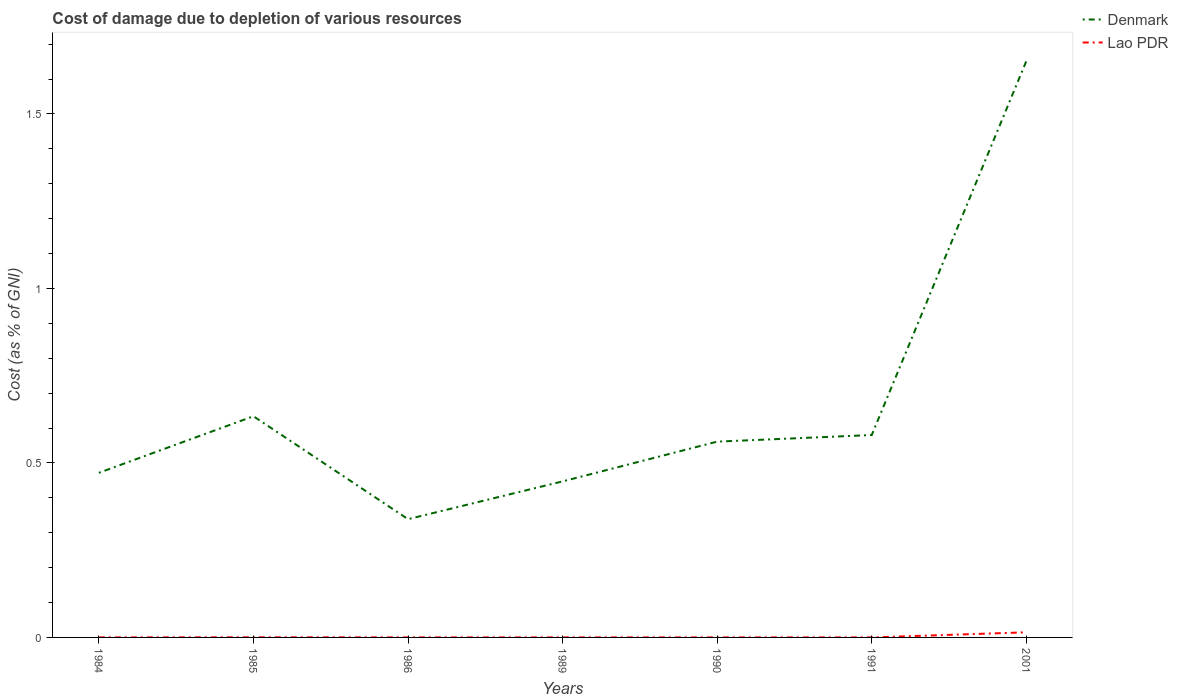How many different coloured lines are there?
Your answer should be compact. 2. Is the number of lines equal to the number of legend labels?
Provide a succinct answer. Yes. Across all years, what is the maximum cost of damage caused due to the depletion of various resources in Lao PDR?
Your response must be concise. 5.99881695392903e-5. What is the total cost of damage caused due to the depletion of various resources in Denmark in the graph?
Provide a succinct answer. -1.31. What is the difference between the highest and the second highest cost of damage caused due to the depletion of various resources in Lao PDR?
Offer a terse response. 0.01. How many lines are there?
Your response must be concise. 2. What is the difference between two consecutive major ticks on the Y-axis?
Provide a short and direct response. 0.5. Does the graph contain any zero values?
Give a very brief answer. No. Does the graph contain grids?
Give a very brief answer. No. Where does the legend appear in the graph?
Give a very brief answer. Top right. How many legend labels are there?
Give a very brief answer. 2. What is the title of the graph?
Keep it short and to the point. Cost of damage due to depletion of various resources. What is the label or title of the Y-axis?
Offer a very short reply. Cost (as % of GNI). What is the Cost (as % of GNI) in Denmark in 1984?
Your answer should be compact. 0.47. What is the Cost (as % of GNI) of Lao PDR in 1984?
Keep it short and to the point. 0. What is the Cost (as % of GNI) in Denmark in 1985?
Offer a terse response. 0.63. What is the Cost (as % of GNI) in Lao PDR in 1985?
Your answer should be compact. 0. What is the Cost (as % of GNI) in Denmark in 1986?
Keep it short and to the point. 0.34. What is the Cost (as % of GNI) of Lao PDR in 1986?
Provide a short and direct response. 0. What is the Cost (as % of GNI) in Denmark in 1989?
Your answer should be compact. 0.45. What is the Cost (as % of GNI) in Lao PDR in 1989?
Your answer should be compact. 7.44864051675228e-5. What is the Cost (as % of GNI) of Denmark in 1990?
Ensure brevity in your answer.  0.56. What is the Cost (as % of GNI) of Lao PDR in 1990?
Offer a very short reply. 0. What is the Cost (as % of GNI) of Denmark in 1991?
Make the answer very short. 0.58. What is the Cost (as % of GNI) in Lao PDR in 1991?
Give a very brief answer. 5.99881695392903e-5. What is the Cost (as % of GNI) of Denmark in 2001?
Offer a terse response. 1.65. What is the Cost (as % of GNI) in Lao PDR in 2001?
Your answer should be very brief. 0.01. Across all years, what is the maximum Cost (as % of GNI) of Denmark?
Ensure brevity in your answer.  1.65. Across all years, what is the maximum Cost (as % of GNI) in Lao PDR?
Ensure brevity in your answer.  0.01. Across all years, what is the minimum Cost (as % of GNI) in Denmark?
Ensure brevity in your answer.  0.34. Across all years, what is the minimum Cost (as % of GNI) in Lao PDR?
Provide a short and direct response. 5.99881695392903e-5. What is the total Cost (as % of GNI) in Denmark in the graph?
Your answer should be compact. 4.68. What is the total Cost (as % of GNI) in Lao PDR in the graph?
Offer a very short reply. 0.02. What is the difference between the Cost (as % of GNI) of Denmark in 1984 and that in 1985?
Offer a terse response. -0.16. What is the difference between the Cost (as % of GNI) in Lao PDR in 1984 and that in 1985?
Offer a terse response. -0. What is the difference between the Cost (as % of GNI) of Denmark in 1984 and that in 1986?
Provide a short and direct response. 0.13. What is the difference between the Cost (as % of GNI) in Denmark in 1984 and that in 1989?
Your answer should be compact. 0.02. What is the difference between the Cost (as % of GNI) of Lao PDR in 1984 and that in 1989?
Your answer should be very brief. 0. What is the difference between the Cost (as % of GNI) of Denmark in 1984 and that in 1990?
Offer a very short reply. -0.09. What is the difference between the Cost (as % of GNI) of Denmark in 1984 and that in 1991?
Your answer should be compact. -0.11. What is the difference between the Cost (as % of GNI) of Lao PDR in 1984 and that in 1991?
Your answer should be compact. 0. What is the difference between the Cost (as % of GNI) in Denmark in 1984 and that in 2001?
Your response must be concise. -1.18. What is the difference between the Cost (as % of GNI) in Lao PDR in 1984 and that in 2001?
Your response must be concise. -0.01. What is the difference between the Cost (as % of GNI) of Denmark in 1985 and that in 1986?
Offer a very short reply. 0.29. What is the difference between the Cost (as % of GNI) of Denmark in 1985 and that in 1989?
Your response must be concise. 0.19. What is the difference between the Cost (as % of GNI) in Denmark in 1985 and that in 1990?
Your answer should be compact. 0.07. What is the difference between the Cost (as % of GNI) of Denmark in 1985 and that in 1991?
Keep it short and to the point. 0.05. What is the difference between the Cost (as % of GNI) of Denmark in 1985 and that in 2001?
Make the answer very short. -1.02. What is the difference between the Cost (as % of GNI) of Lao PDR in 1985 and that in 2001?
Your answer should be compact. -0.01. What is the difference between the Cost (as % of GNI) in Denmark in 1986 and that in 1989?
Offer a terse response. -0.11. What is the difference between the Cost (as % of GNI) of Denmark in 1986 and that in 1990?
Ensure brevity in your answer.  -0.22. What is the difference between the Cost (as % of GNI) in Denmark in 1986 and that in 1991?
Give a very brief answer. -0.24. What is the difference between the Cost (as % of GNI) in Denmark in 1986 and that in 2001?
Your response must be concise. -1.31. What is the difference between the Cost (as % of GNI) in Lao PDR in 1986 and that in 2001?
Keep it short and to the point. -0.01. What is the difference between the Cost (as % of GNI) in Denmark in 1989 and that in 1990?
Ensure brevity in your answer.  -0.11. What is the difference between the Cost (as % of GNI) of Lao PDR in 1989 and that in 1990?
Ensure brevity in your answer.  -0. What is the difference between the Cost (as % of GNI) of Denmark in 1989 and that in 1991?
Give a very brief answer. -0.13. What is the difference between the Cost (as % of GNI) of Lao PDR in 1989 and that in 1991?
Provide a succinct answer. 0. What is the difference between the Cost (as % of GNI) of Denmark in 1989 and that in 2001?
Offer a very short reply. -1.2. What is the difference between the Cost (as % of GNI) of Lao PDR in 1989 and that in 2001?
Your response must be concise. -0.01. What is the difference between the Cost (as % of GNI) in Denmark in 1990 and that in 1991?
Give a very brief answer. -0.02. What is the difference between the Cost (as % of GNI) of Lao PDR in 1990 and that in 1991?
Offer a very short reply. 0. What is the difference between the Cost (as % of GNI) of Denmark in 1990 and that in 2001?
Offer a terse response. -1.09. What is the difference between the Cost (as % of GNI) in Lao PDR in 1990 and that in 2001?
Give a very brief answer. -0.01. What is the difference between the Cost (as % of GNI) of Denmark in 1991 and that in 2001?
Offer a terse response. -1.07. What is the difference between the Cost (as % of GNI) of Lao PDR in 1991 and that in 2001?
Offer a terse response. -0.01. What is the difference between the Cost (as % of GNI) in Denmark in 1984 and the Cost (as % of GNI) in Lao PDR in 1985?
Your response must be concise. 0.47. What is the difference between the Cost (as % of GNI) in Denmark in 1984 and the Cost (as % of GNI) in Lao PDR in 1986?
Ensure brevity in your answer.  0.47. What is the difference between the Cost (as % of GNI) of Denmark in 1984 and the Cost (as % of GNI) of Lao PDR in 1989?
Give a very brief answer. 0.47. What is the difference between the Cost (as % of GNI) in Denmark in 1984 and the Cost (as % of GNI) in Lao PDR in 1990?
Give a very brief answer. 0.47. What is the difference between the Cost (as % of GNI) of Denmark in 1984 and the Cost (as % of GNI) of Lao PDR in 1991?
Keep it short and to the point. 0.47. What is the difference between the Cost (as % of GNI) of Denmark in 1984 and the Cost (as % of GNI) of Lao PDR in 2001?
Your response must be concise. 0.46. What is the difference between the Cost (as % of GNI) of Denmark in 1985 and the Cost (as % of GNI) of Lao PDR in 1986?
Keep it short and to the point. 0.63. What is the difference between the Cost (as % of GNI) in Denmark in 1985 and the Cost (as % of GNI) in Lao PDR in 1989?
Make the answer very short. 0.63. What is the difference between the Cost (as % of GNI) of Denmark in 1985 and the Cost (as % of GNI) of Lao PDR in 1990?
Provide a short and direct response. 0.63. What is the difference between the Cost (as % of GNI) of Denmark in 1985 and the Cost (as % of GNI) of Lao PDR in 1991?
Your answer should be compact. 0.63. What is the difference between the Cost (as % of GNI) in Denmark in 1985 and the Cost (as % of GNI) in Lao PDR in 2001?
Give a very brief answer. 0.62. What is the difference between the Cost (as % of GNI) in Denmark in 1986 and the Cost (as % of GNI) in Lao PDR in 1989?
Your answer should be very brief. 0.34. What is the difference between the Cost (as % of GNI) of Denmark in 1986 and the Cost (as % of GNI) of Lao PDR in 1990?
Provide a succinct answer. 0.34. What is the difference between the Cost (as % of GNI) in Denmark in 1986 and the Cost (as % of GNI) in Lao PDR in 1991?
Ensure brevity in your answer.  0.34. What is the difference between the Cost (as % of GNI) in Denmark in 1986 and the Cost (as % of GNI) in Lao PDR in 2001?
Your answer should be very brief. 0.32. What is the difference between the Cost (as % of GNI) in Denmark in 1989 and the Cost (as % of GNI) in Lao PDR in 1990?
Offer a very short reply. 0.45. What is the difference between the Cost (as % of GNI) of Denmark in 1989 and the Cost (as % of GNI) of Lao PDR in 1991?
Ensure brevity in your answer.  0.45. What is the difference between the Cost (as % of GNI) of Denmark in 1989 and the Cost (as % of GNI) of Lao PDR in 2001?
Provide a short and direct response. 0.43. What is the difference between the Cost (as % of GNI) in Denmark in 1990 and the Cost (as % of GNI) in Lao PDR in 1991?
Your answer should be compact. 0.56. What is the difference between the Cost (as % of GNI) of Denmark in 1990 and the Cost (as % of GNI) of Lao PDR in 2001?
Your answer should be very brief. 0.55. What is the difference between the Cost (as % of GNI) of Denmark in 1991 and the Cost (as % of GNI) of Lao PDR in 2001?
Ensure brevity in your answer.  0.57. What is the average Cost (as % of GNI) in Denmark per year?
Keep it short and to the point. 0.67. What is the average Cost (as % of GNI) of Lao PDR per year?
Offer a terse response. 0. In the year 1984, what is the difference between the Cost (as % of GNI) of Denmark and Cost (as % of GNI) of Lao PDR?
Give a very brief answer. 0.47. In the year 1985, what is the difference between the Cost (as % of GNI) of Denmark and Cost (as % of GNI) of Lao PDR?
Your answer should be very brief. 0.63. In the year 1986, what is the difference between the Cost (as % of GNI) in Denmark and Cost (as % of GNI) in Lao PDR?
Your answer should be very brief. 0.34. In the year 1989, what is the difference between the Cost (as % of GNI) in Denmark and Cost (as % of GNI) in Lao PDR?
Your answer should be very brief. 0.45. In the year 1990, what is the difference between the Cost (as % of GNI) of Denmark and Cost (as % of GNI) of Lao PDR?
Offer a very short reply. 0.56. In the year 1991, what is the difference between the Cost (as % of GNI) in Denmark and Cost (as % of GNI) in Lao PDR?
Offer a very short reply. 0.58. In the year 2001, what is the difference between the Cost (as % of GNI) of Denmark and Cost (as % of GNI) of Lao PDR?
Provide a short and direct response. 1.64. What is the ratio of the Cost (as % of GNI) in Denmark in 1984 to that in 1985?
Ensure brevity in your answer.  0.74. What is the ratio of the Cost (as % of GNI) in Lao PDR in 1984 to that in 1985?
Give a very brief answer. 0.38. What is the ratio of the Cost (as % of GNI) of Denmark in 1984 to that in 1986?
Give a very brief answer. 1.39. What is the ratio of the Cost (as % of GNI) of Lao PDR in 1984 to that in 1986?
Ensure brevity in your answer.  0.78. What is the ratio of the Cost (as % of GNI) of Denmark in 1984 to that in 1989?
Give a very brief answer. 1.05. What is the ratio of the Cost (as % of GNI) in Lao PDR in 1984 to that in 1989?
Make the answer very short. 1.54. What is the ratio of the Cost (as % of GNI) in Denmark in 1984 to that in 1990?
Offer a terse response. 0.84. What is the ratio of the Cost (as % of GNI) of Lao PDR in 1984 to that in 1990?
Your answer should be very brief. 1.08. What is the ratio of the Cost (as % of GNI) in Denmark in 1984 to that in 1991?
Your answer should be compact. 0.81. What is the ratio of the Cost (as % of GNI) of Lao PDR in 1984 to that in 1991?
Give a very brief answer. 1.91. What is the ratio of the Cost (as % of GNI) of Denmark in 1984 to that in 2001?
Give a very brief answer. 0.29. What is the ratio of the Cost (as % of GNI) in Lao PDR in 1984 to that in 2001?
Provide a short and direct response. 0.01. What is the ratio of the Cost (as % of GNI) in Denmark in 1985 to that in 1986?
Offer a terse response. 1.87. What is the ratio of the Cost (as % of GNI) of Lao PDR in 1985 to that in 1986?
Make the answer very short. 2.06. What is the ratio of the Cost (as % of GNI) of Denmark in 1985 to that in 1989?
Provide a succinct answer. 1.42. What is the ratio of the Cost (as % of GNI) of Lao PDR in 1985 to that in 1989?
Your response must be concise. 4.06. What is the ratio of the Cost (as % of GNI) in Denmark in 1985 to that in 1990?
Offer a very short reply. 1.13. What is the ratio of the Cost (as % of GNI) in Lao PDR in 1985 to that in 1990?
Ensure brevity in your answer.  2.85. What is the ratio of the Cost (as % of GNI) in Denmark in 1985 to that in 1991?
Your answer should be compact. 1.09. What is the ratio of the Cost (as % of GNI) of Lao PDR in 1985 to that in 1991?
Provide a short and direct response. 5.04. What is the ratio of the Cost (as % of GNI) of Denmark in 1985 to that in 2001?
Make the answer very short. 0.38. What is the ratio of the Cost (as % of GNI) of Lao PDR in 1985 to that in 2001?
Your answer should be compact. 0.02. What is the ratio of the Cost (as % of GNI) in Denmark in 1986 to that in 1989?
Provide a succinct answer. 0.76. What is the ratio of the Cost (as % of GNI) of Lao PDR in 1986 to that in 1989?
Provide a short and direct response. 1.97. What is the ratio of the Cost (as % of GNI) in Denmark in 1986 to that in 1990?
Provide a short and direct response. 0.6. What is the ratio of the Cost (as % of GNI) in Lao PDR in 1986 to that in 1990?
Your response must be concise. 1.38. What is the ratio of the Cost (as % of GNI) in Denmark in 1986 to that in 1991?
Give a very brief answer. 0.58. What is the ratio of the Cost (as % of GNI) of Lao PDR in 1986 to that in 1991?
Provide a short and direct response. 2.44. What is the ratio of the Cost (as % of GNI) of Denmark in 1986 to that in 2001?
Offer a very short reply. 0.21. What is the ratio of the Cost (as % of GNI) in Denmark in 1989 to that in 1990?
Offer a terse response. 0.8. What is the ratio of the Cost (as % of GNI) in Lao PDR in 1989 to that in 1990?
Ensure brevity in your answer.  0.7. What is the ratio of the Cost (as % of GNI) in Denmark in 1989 to that in 1991?
Keep it short and to the point. 0.77. What is the ratio of the Cost (as % of GNI) of Lao PDR in 1989 to that in 1991?
Give a very brief answer. 1.24. What is the ratio of the Cost (as % of GNI) in Denmark in 1989 to that in 2001?
Make the answer very short. 0.27. What is the ratio of the Cost (as % of GNI) in Lao PDR in 1989 to that in 2001?
Ensure brevity in your answer.  0.01. What is the ratio of the Cost (as % of GNI) in Denmark in 1990 to that in 1991?
Your answer should be very brief. 0.97. What is the ratio of the Cost (as % of GNI) in Lao PDR in 1990 to that in 1991?
Your response must be concise. 1.77. What is the ratio of the Cost (as % of GNI) of Denmark in 1990 to that in 2001?
Give a very brief answer. 0.34. What is the ratio of the Cost (as % of GNI) in Lao PDR in 1990 to that in 2001?
Offer a terse response. 0.01. What is the ratio of the Cost (as % of GNI) of Denmark in 1991 to that in 2001?
Your answer should be compact. 0.35. What is the ratio of the Cost (as % of GNI) in Lao PDR in 1991 to that in 2001?
Ensure brevity in your answer.  0. What is the difference between the highest and the second highest Cost (as % of GNI) in Denmark?
Your answer should be compact. 1.02. What is the difference between the highest and the second highest Cost (as % of GNI) in Lao PDR?
Your answer should be very brief. 0.01. What is the difference between the highest and the lowest Cost (as % of GNI) of Denmark?
Give a very brief answer. 1.31. What is the difference between the highest and the lowest Cost (as % of GNI) in Lao PDR?
Offer a terse response. 0.01. 